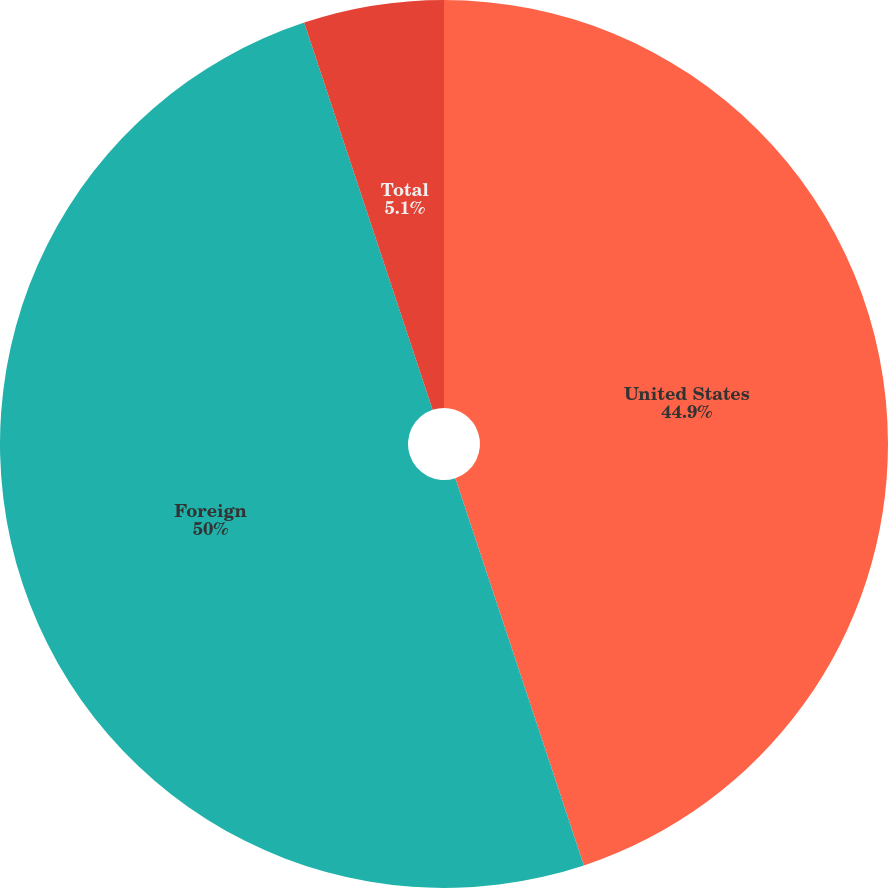<chart> <loc_0><loc_0><loc_500><loc_500><pie_chart><fcel>United States<fcel>Foreign<fcel>Total<nl><fcel>44.9%<fcel>50.0%<fcel>5.1%<nl></chart> 